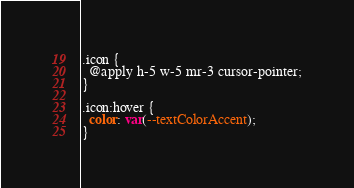Convert code to text. <code><loc_0><loc_0><loc_500><loc_500><_CSS_>.icon {
  @apply h-5 w-5 mr-3 cursor-pointer;
}

.icon:hover {
  color: var(--textColorAccent);
}</code> 